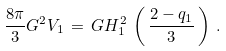<formula> <loc_0><loc_0><loc_500><loc_500>\frac { 8 \pi } { 3 } G ^ { 2 } V _ { 1 } \, = \, G H ^ { 2 } _ { 1 } \, \left ( \, \frac { 2 - q _ { 1 } } { 3 } \, \right ) \, .</formula> 